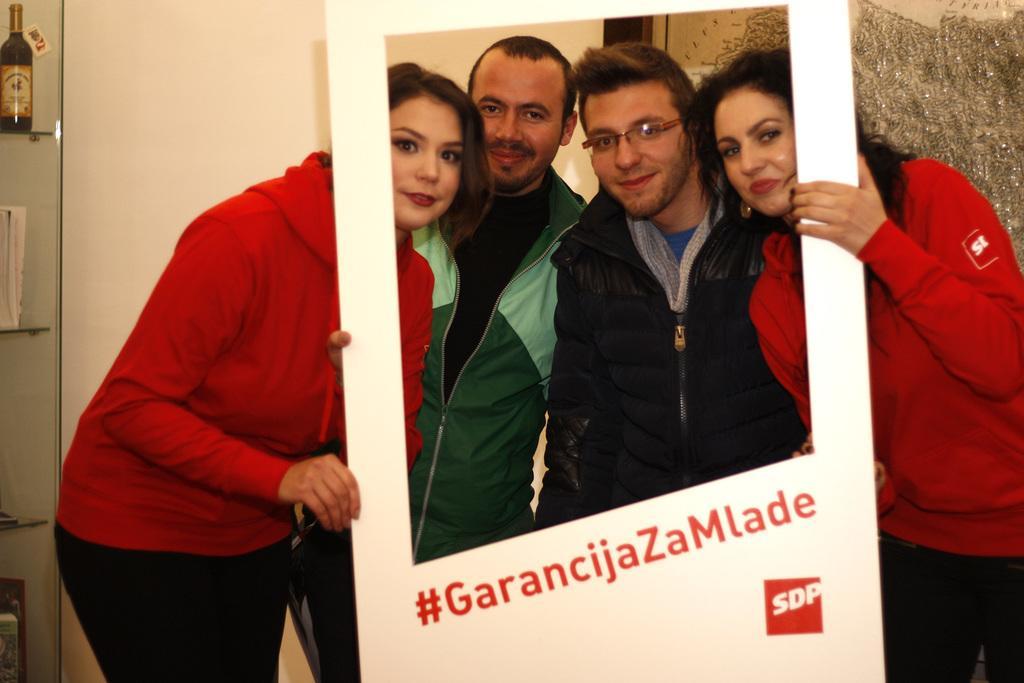In one or two sentences, can you explain what this image depicts? In this image I see 2 women who are wearing red top and black pants and I see men who are wearing jackets and I see that these 2 women are holding a white board on which there are words written and in the background I see the wall and I see a bottle over here. 